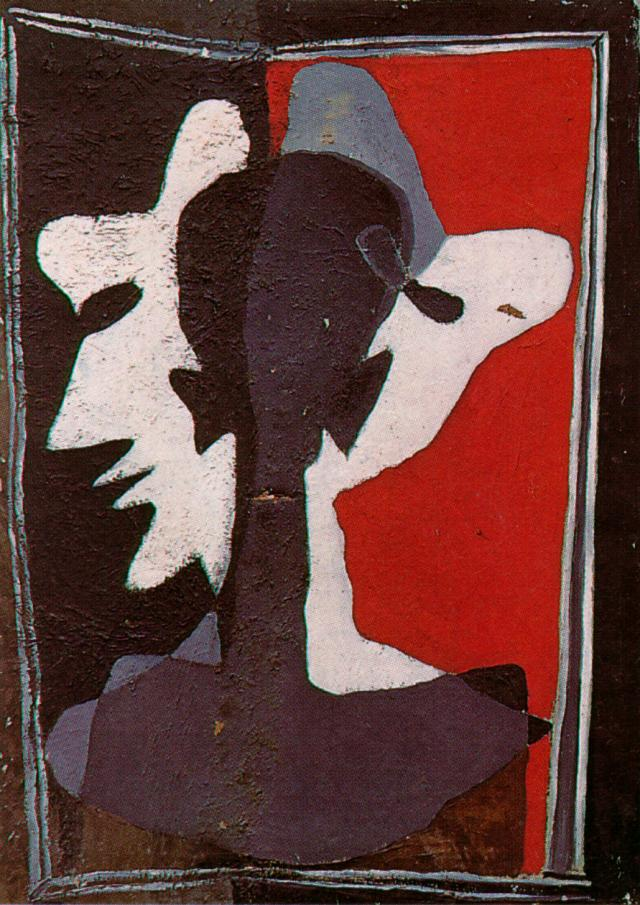Describe the following image. The image showcases an abstract composition with a striking contrast of colors and forms. Set against a vivid red background, the central area is dominated by overlapping silhouettes of faces in shades of black, white, and gray. These forms create a sense of depth and movement, as if the faces are engaged in a silent dialogue. The rough texture and the contrasting use of colors — ranging from the stark white to the deep black — draw the viewer's attention to the emotional intensity of the piece. Encircled by a rough black border, the image evokes an impression of both confinement and focus, encapsulating the viewer within its realm of abstract expressionism. 